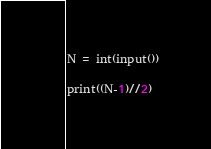Convert code to text. <code><loc_0><loc_0><loc_500><loc_500><_Python_>N = int(input())

print((N-1)//2)</code> 